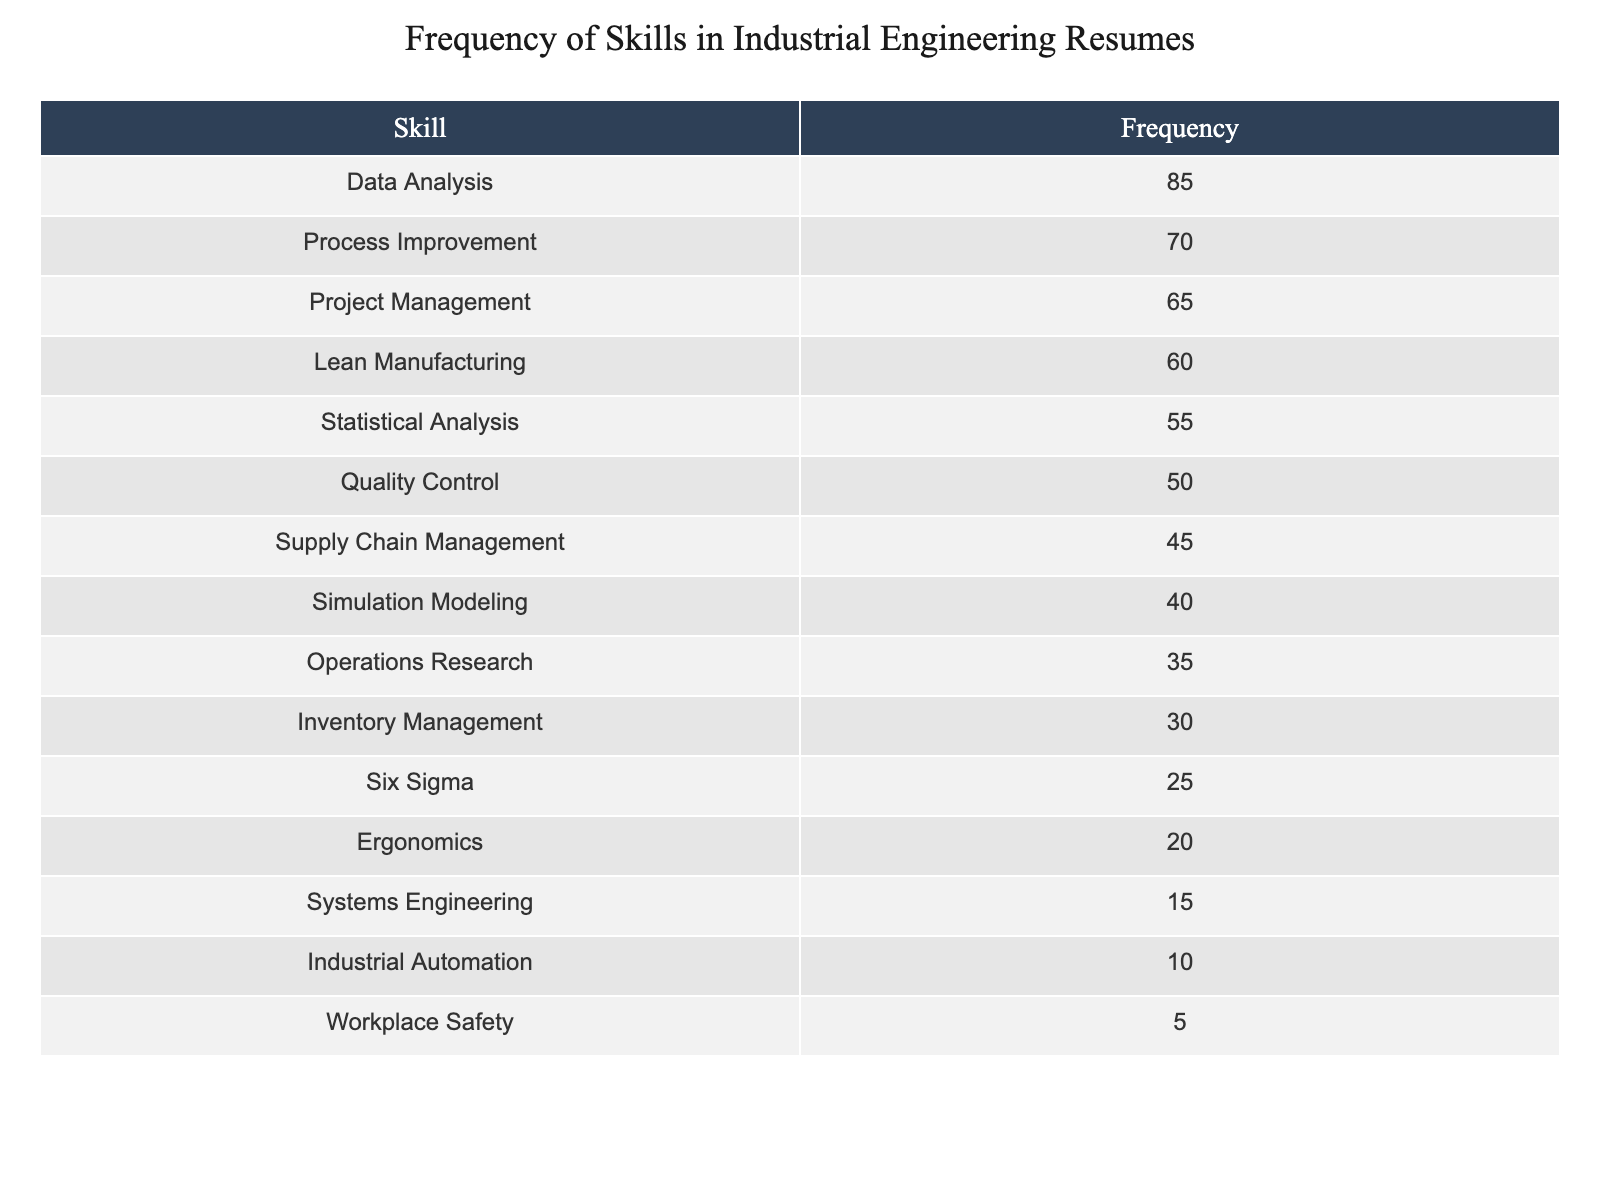What is the frequency of Data Analysis skills listed on resumes? The frequency of Data Analysis skills is given directly in the table. Looking at the row for Data Analysis, the frequency value is 85.
Answer: 85 Which skill has the lowest frequency on the resumes? To find the skill with the lowest frequency, I need to look at all the skills listed and identify the one with the smallest frequency. The skill with the lowest frequency is Workplace Safety with a frequency of 5.
Answer: Workplace Safety What is the total frequency of skills related to Quality Control, Statistical Analysis, and Process Improvement? I will sum the frequencies of the three specified skills: Quality Control (50), Statistical Analysis (55), and Process Improvement (70). Adding these gives: 50 + 55 + 70 = 175.
Answer: 175 Is Six Sigma more frequently listed than Supply Chain Management? To answer this question, I will compare the frequencies of Six Sigma and Supply Chain Management from the table. Six Sigma has a frequency of 25, while Supply Chain Management has a frequency of 45. Since 25 is less than 45, the answer is no.
Answer: No What is the average frequency of the top three skills listed? First, I identify the top three skills based on frequency: Data Analysis (85), Process Improvement (70), and Project Management (65). I sum these frequencies: 85 + 70 + 65 = 220. There are three skills, so I divide by 3 to find the average: 220 / 3 = 73.33.
Answer: 73.33 How many skills have a frequency of 50 or more? I will check each skill's frequency and count how many are greater than or equal to 50. Data Analysis (85), Process Improvement (70), Project Management (65), Lean Manufacturing (60), Statistical Analysis (55), and Quality Control (50) all meet this criterion. This results in a total of 6 skills.
Answer: 6 If we combine the frequencies of Ergonomics, Systems Engineering, and Industrial Automation, what is the total? I will add the frequencies of Ergonomics (20), Systems Engineering (15), and Industrial Automation (10). The total is 20 + 15 + 10 = 45.
Answer: 45 Which skill has a frequency that is 10 less than the frequency of Simulation Modeling? The frequency of Simulation Modeling is 40. I subtract 10 from this number to find the frequency in question, which is 30. Looking at the table, the skill with a frequency of 30 is Inventory Management.
Answer: Inventory Management 